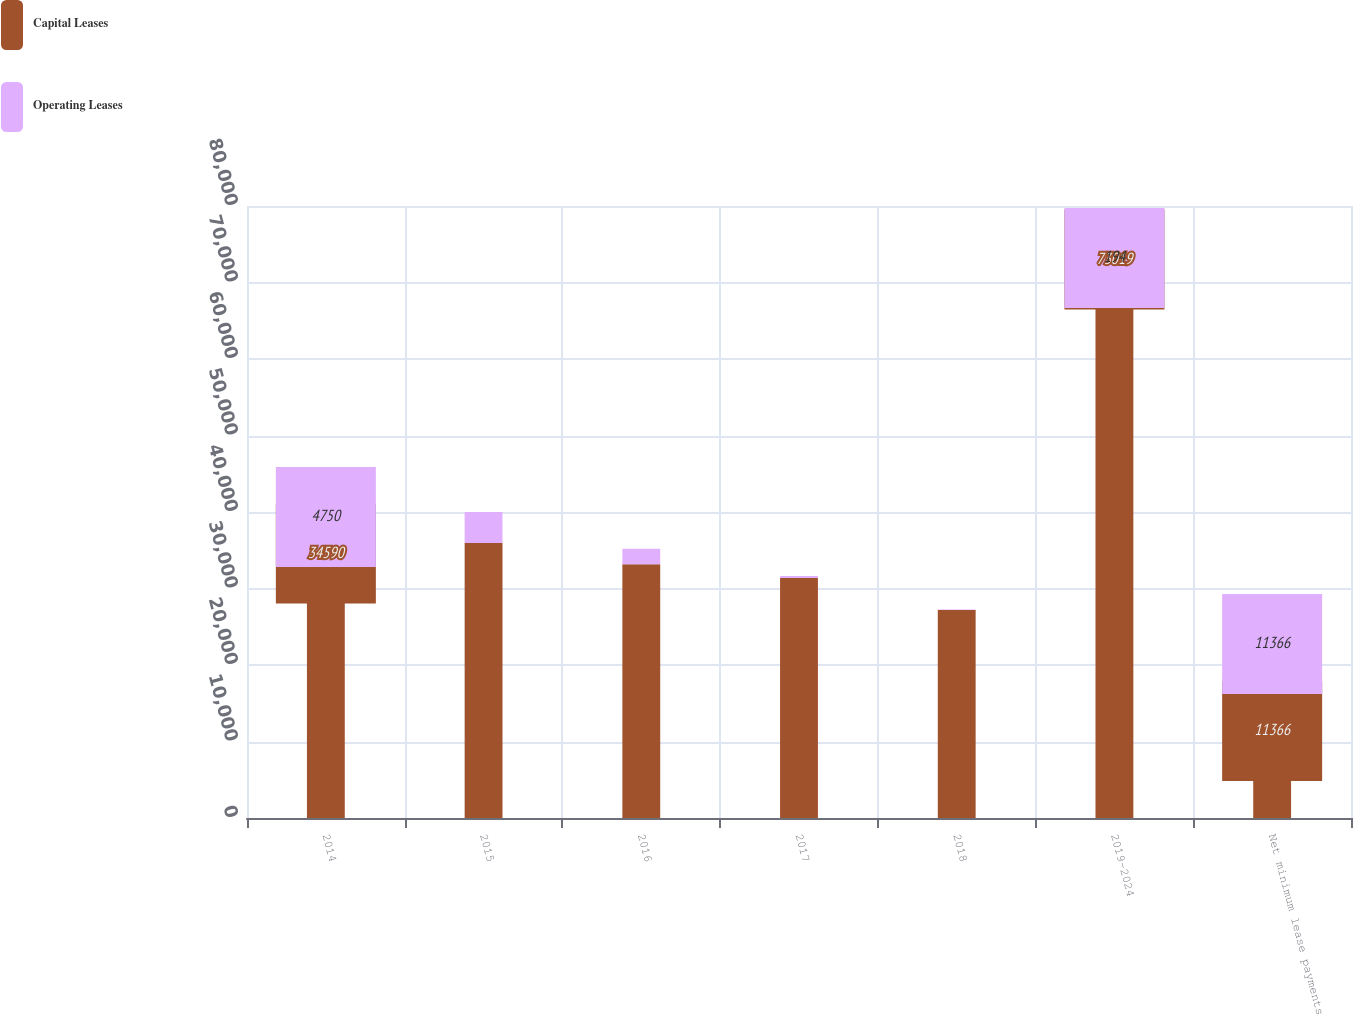Convert chart to OTSL. <chart><loc_0><loc_0><loc_500><loc_500><stacked_bar_chart><ecel><fcel>2014<fcel>2015<fcel>2016<fcel>2017<fcel>2018<fcel>2019-2024<fcel>Net minimum lease payments<nl><fcel>Capital Leases<fcel>34590<fcel>35957<fcel>33171<fcel>31362<fcel>27182<fcel>73019<fcel>11366<nl><fcel>Operating Leases<fcel>4750<fcel>4059<fcel>2034<fcel>256<fcel>73<fcel>194<fcel>11366<nl></chart> 